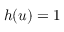<formula> <loc_0><loc_0><loc_500><loc_500>h ( u ) = 1</formula> 